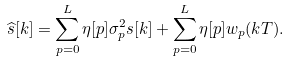Convert formula to latex. <formula><loc_0><loc_0><loc_500><loc_500>\widehat { s } [ k ] = \sum _ { p = 0 } ^ { L } \eta [ p ] \sigma _ { p } ^ { 2 } s [ k ] + \sum _ { p = 0 } ^ { L } \eta [ p ] w _ { p } ( k T ) .</formula> 